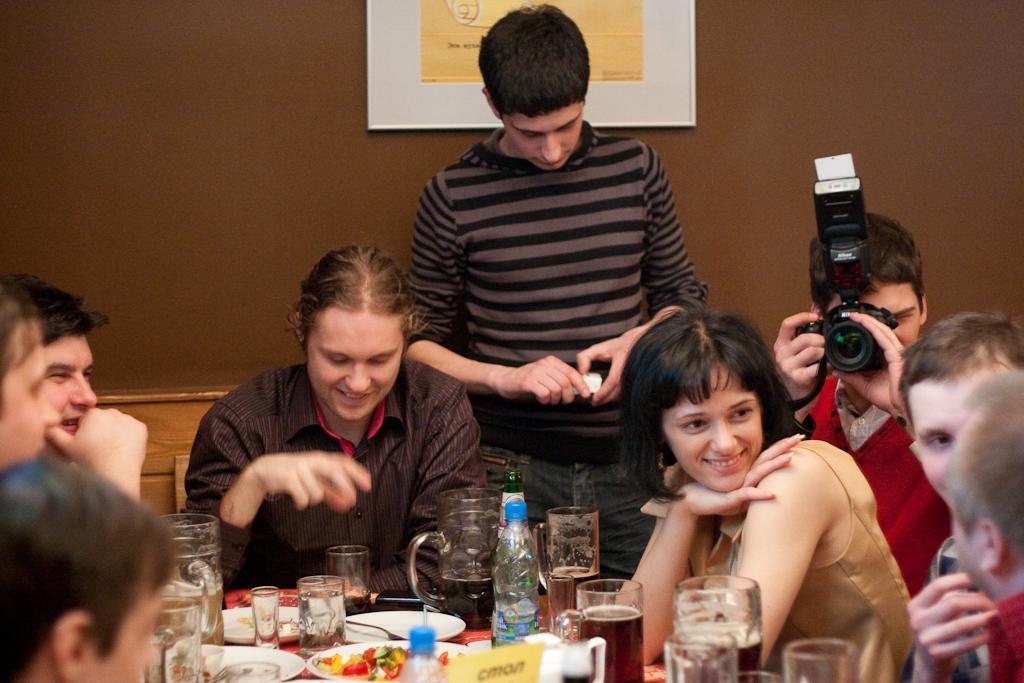Can you describe this image briefly? In this given picture there are some group of people sitting around a table. On the table there is some food items glasses, jars and water bottles here. There are women and men in this group. One guy standing, beside the standing guy, there is a guy taking the photographs with a camera. In the background there is a wall here. 